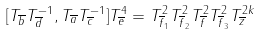Convert formula to latex. <formula><loc_0><loc_0><loc_500><loc_500>[ T _ { \overline { b } } T _ { \overline { d } } ^ { - 1 } , T _ { \overline { a } } T _ { \overline { c } } ^ { - 1 } ] T _ { \overline { e } } ^ { 4 } = T _ { \overline { f } _ { 1 } } ^ { 2 } T _ { \overline { f } _ { 2 } } ^ { 2 } T _ { \overline { f } } ^ { 2 } T _ { \overline { f } _ { 3 } } ^ { 2 } T _ { \overline { z } } ^ { 2 k }</formula> 